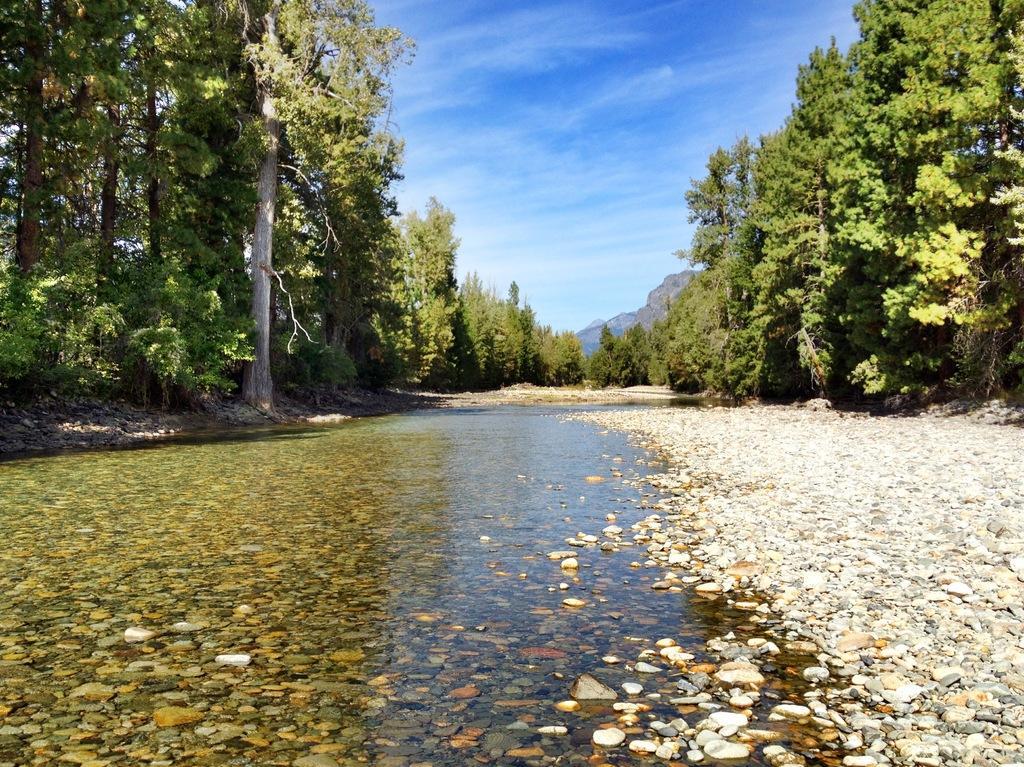In one or two sentences, can you explain what this image depicts? In this picture we can see many trees. At the bottom we can see water and stones. In the background there is a mountain. At the top we can see sky and clouds. 